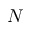<formula> <loc_0><loc_0><loc_500><loc_500>N</formula> 